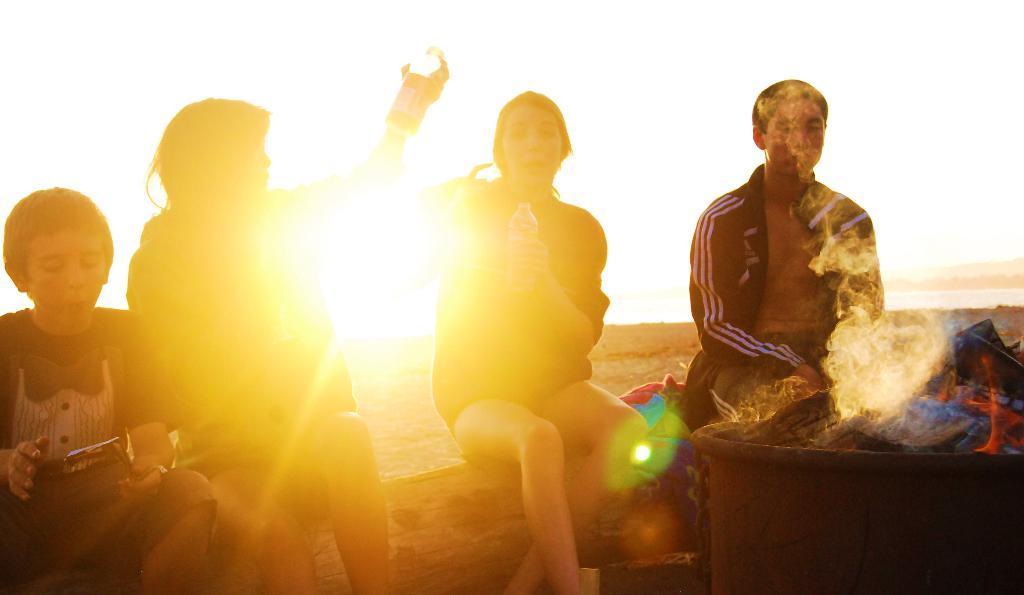Please provide a concise description of this image. Here in this picture we can see a group of people sitting on a wooden log and in front of them we can see a fireplace present on the ground and behind them we can see sun present in the sky and we can see the two women in the middle are holding water bottle in their hands. 